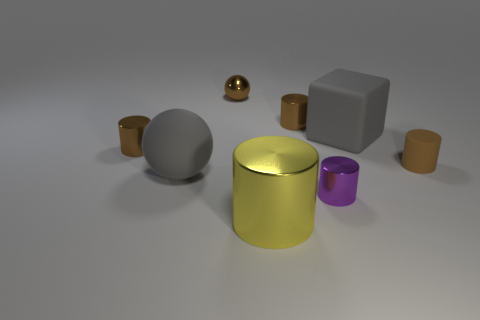Do the big metal object and the small purple shiny thing have the same shape?
Offer a very short reply. Yes. How many other objects are the same size as the gray sphere?
Make the answer very short. 2. What is the color of the small sphere?
Provide a short and direct response. Brown. How many large things are red cubes or purple cylinders?
Your answer should be very brief. 0. Do the matte block that is behind the yellow shiny cylinder and the gray rubber object that is on the left side of the purple metal cylinder have the same size?
Provide a succinct answer. Yes. There is another purple metal object that is the same shape as the big metallic thing; what size is it?
Provide a succinct answer. Small. Are there more brown cylinders behind the tiny rubber cylinder than gray rubber things that are left of the small purple cylinder?
Offer a terse response. Yes. There is a cylinder that is both to the left of the small purple cylinder and in front of the gray rubber ball; what is its material?
Make the answer very short. Metal. What color is the big metal object that is the same shape as the small brown matte thing?
Offer a very short reply. Yellow. The matte sphere has what size?
Your answer should be compact. Large. 